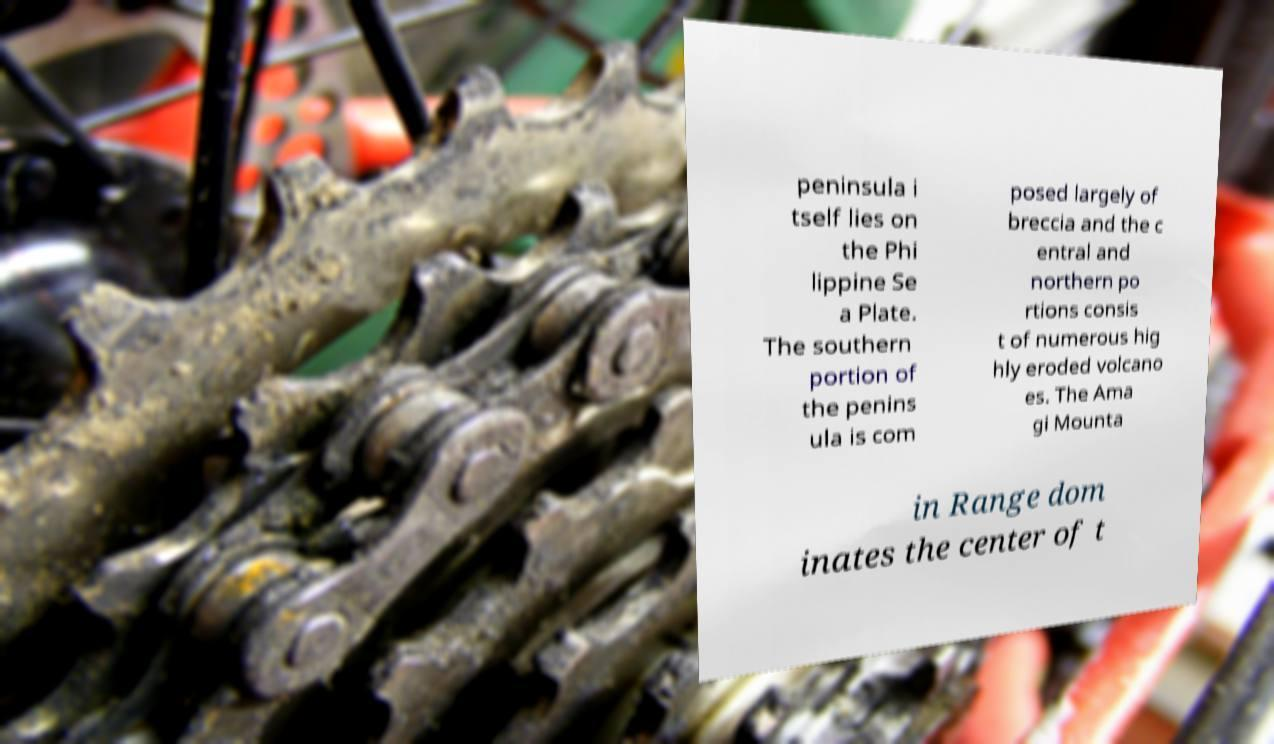Could you assist in decoding the text presented in this image and type it out clearly? peninsula i tself lies on the Phi lippine Se a Plate. The southern portion of the penins ula is com posed largely of breccia and the c entral and northern po rtions consis t of numerous hig hly eroded volcano es. The Ama gi Mounta in Range dom inates the center of t 